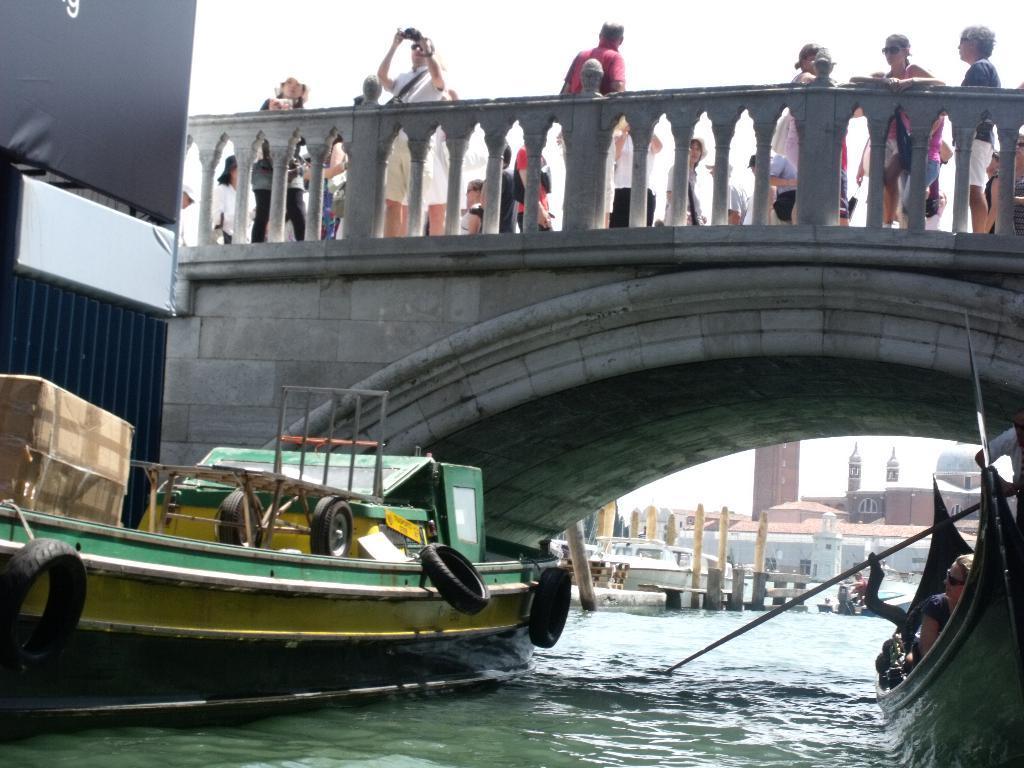How would you summarize this image in a sentence or two? In this picture we can see a boat in the water. There is a box, black objects and a few things visible on the boat. We can see a person visible on a boat on the right side. It looks like a rod. We can see an arch on a bridge. There are a few people visible on this bridge. We can see some people are holding objects in their hands. There are a few poles and houses visible in the background. We can see an object on the left side. 